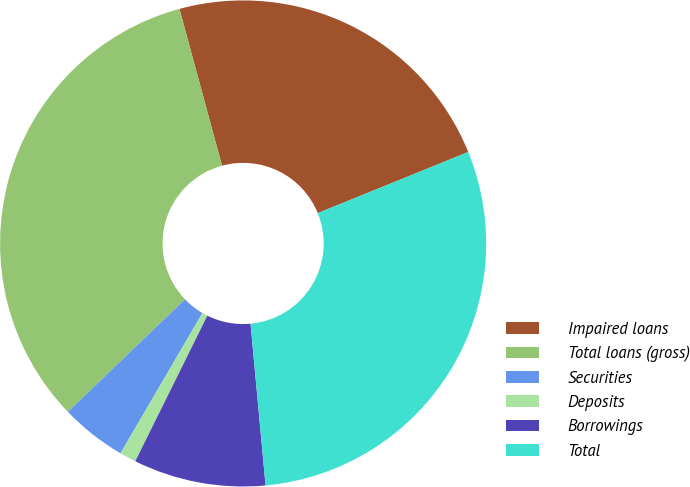Convert chart. <chart><loc_0><loc_0><loc_500><loc_500><pie_chart><fcel>Impaired loans<fcel>Total loans (gross)<fcel>Securities<fcel>Deposits<fcel>Borrowings<fcel>Total<nl><fcel>23.08%<fcel>32.97%<fcel>4.4%<fcel>1.1%<fcel>8.79%<fcel>29.67%<nl></chart> 